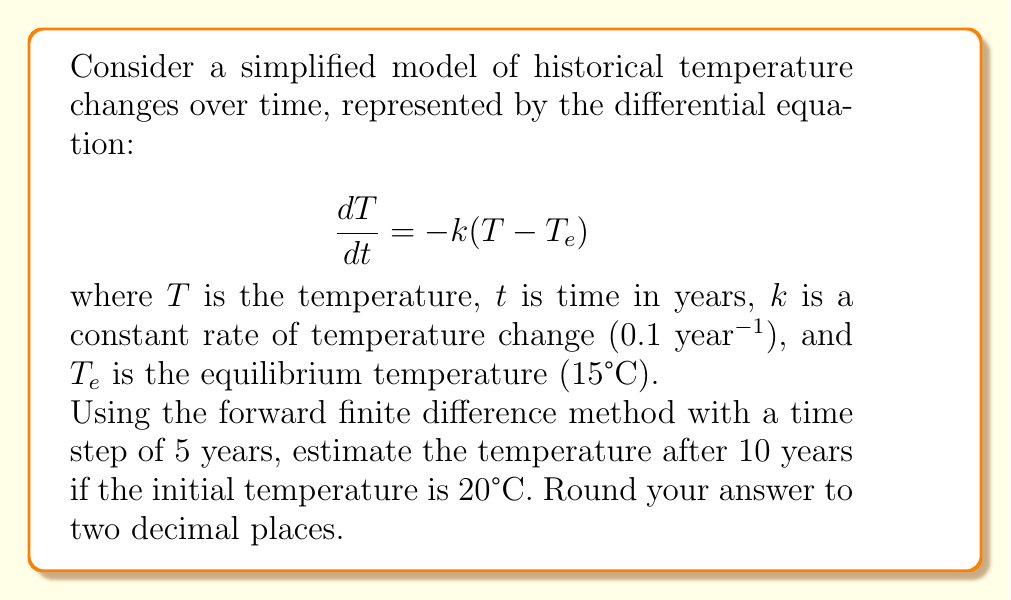Can you solve this math problem? 1) The forward finite difference approximation for the first derivative is:

   $$\frac{dT}{dt} \approx \frac{T_{n+1} - T_n}{\Delta t}$$

2) Substituting this into the original differential equation:

   $$\frac{T_{n+1} - T_n}{\Delta t} = -k(T_n - T_e)$$

3) Rearranging to solve for $T_{n+1}$:

   $$T_{n+1} = T_n - k\Delta t(T_n - T_e)$$

4) Given:
   - $k = 0.1$ year$^{-1}$
   - $T_e = 15°C$
   - $\Delta t = 5$ years
   - Initial temperature $T_0 = 20°C$

5) Calculate temperature after 5 years ($T_1$):

   $$T_1 = 20 - 0.1 \cdot 5(20 - 15) = 17.5°C$$

6) Calculate temperature after 10 years ($T_2$):

   $$T_2 = 17.5 - 0.1 \cdot 5(17.5 - 15) = 16.25°C$$

7) Rounding to two decimal places: 16.25°C
Answer: 16.25°C 